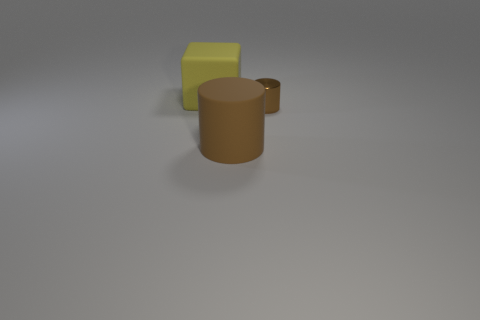What number of blue objects are either rubber cubes or small objects?
Your answer should be very brief. 0. What material is the brown object behind the matte cylinder?
Provide a short and direct response. Metal. There is a large object on the right side of the large rubber block; how many tiny brown metal objects are to the left of it?
Ensure brevity in your answer.  0. How many large yellow matte things are the same shape as the tiny brown shiny object?
Provide a succinct answer. 0. What number of small purple cylinders are there?
Give a very brief answer. 0. What is the color of the large object in front of the brown shiny thing?
Provide a succinct answer. Brown. There is a large rubber thing in front of the large yellow matte cube that is behind the brown matte thing; what is its color?
Your response must be concise. Brown. What color is the matte cylinder that is the same size as the yellow thing?
Offer a very short reply. Brown. What number of objects are to the right of the yellow cube and behind the large brown matte object?
Your response must be concise. 1. What is the shape of the large thing that is the same color as the metallic cylinder?
Ensure brevity in your answer.  Cylinder. 